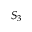<formula> <loc_0><loc_0><loc_500><loc_500>S _ { 3 }</formula> 